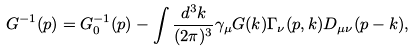<formula> <loc_0><loc_0><loc_500><loc_500>G ^ { - 1 } ( p ) = G _ { 0 } ^ { - 1 } ( p ) - \int \frac { d ^ { 3 } k } { ( 2 \pi ) ^ { 3 } } \gamma _ { \mu } G ( k ) \Gamma _ { \nu } ( p , k ) D _ { \mu \nu } ( p - k ) ,</formula> 